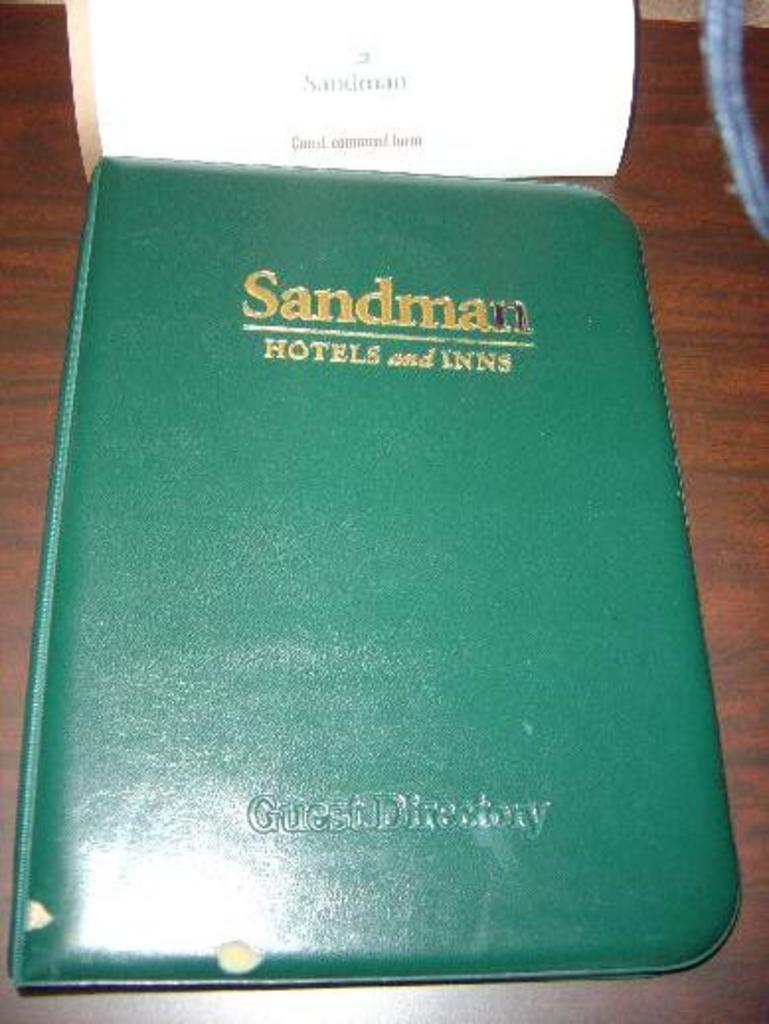<image>
Describe the image concisely. The green book on the table is a guest directory. 